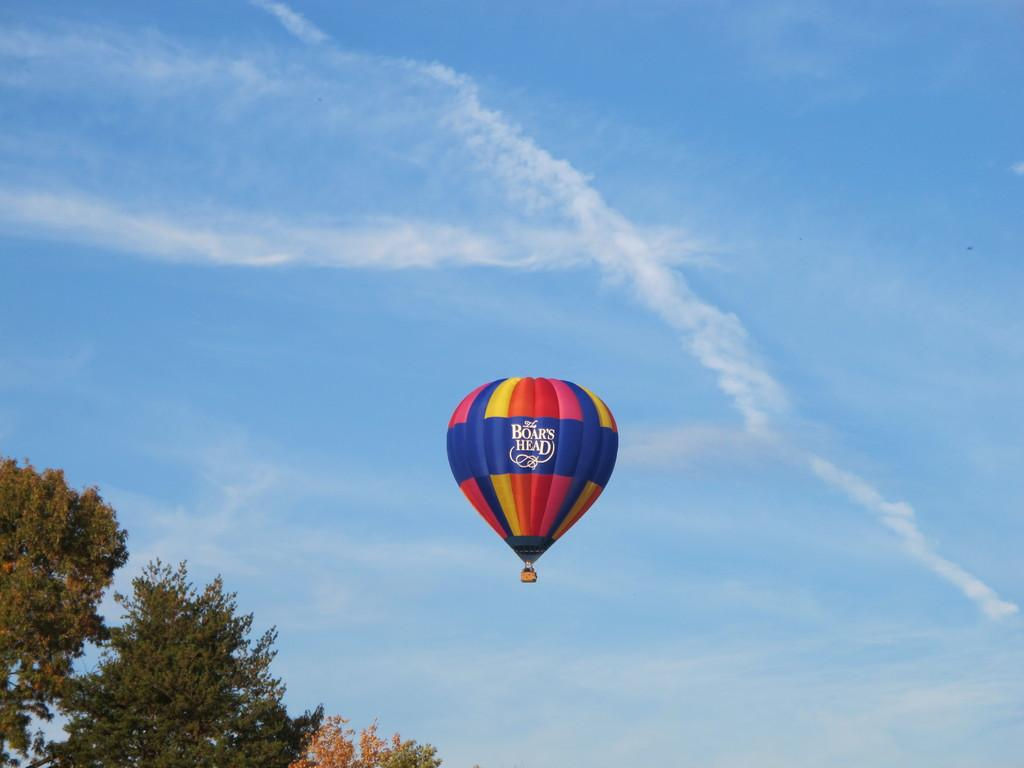What is the main subject of the image? The main subject of the image is an air balloon. Where is the air balloon located in the image? The air balloon is in the air. What type of vegetation can be seen in the image? There are trees visible in the image. How would you describe the sky in the image? The sky is cloudy and pale blue in the image. What type of volleyball game is being played in the image? There is no volleyball game present in the image; it features an air balloon in the air. Whose birthday is being celebrated in the image? There is no indication of a birthday celebration in the image. 